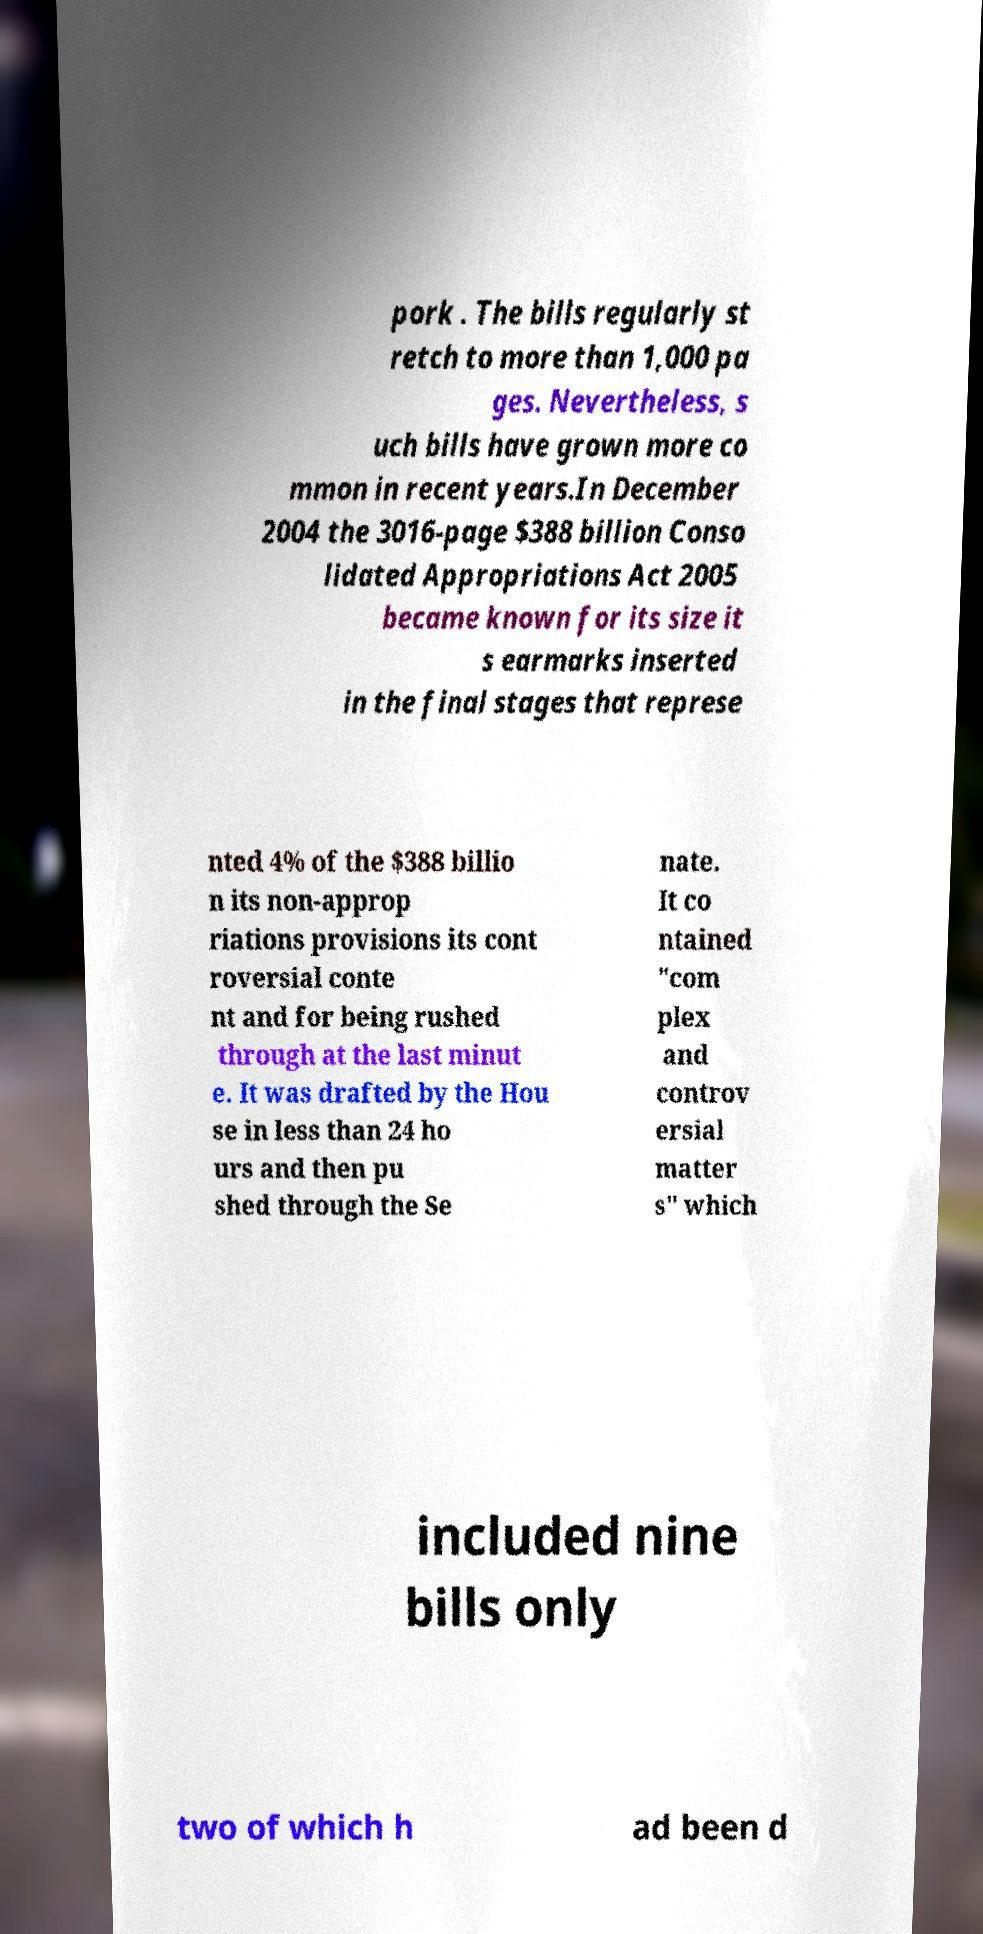Please read and relay the text visible in this image. What does it say? pork . The bills regularly st retch to more than 1,000 pa ges. Nevertheless, s uch bills have grown more co mmon in recent years.In December 2004 the 3016-page $388 billion Conso lidated Appropriations Act 2005 became known for its size it s earmarks inserted in the final stages that represe nted 4% of the $388 billio n its non-approp riations provisions its cont roversial conte nt and for being rushed through at the last minut e. It was drafted by the Hou se in less than 24 ho urs and then pu shed through the Se nate. It co ntained "com plex and controv ersial matter s" which included nine bills only two of which h ad been d 